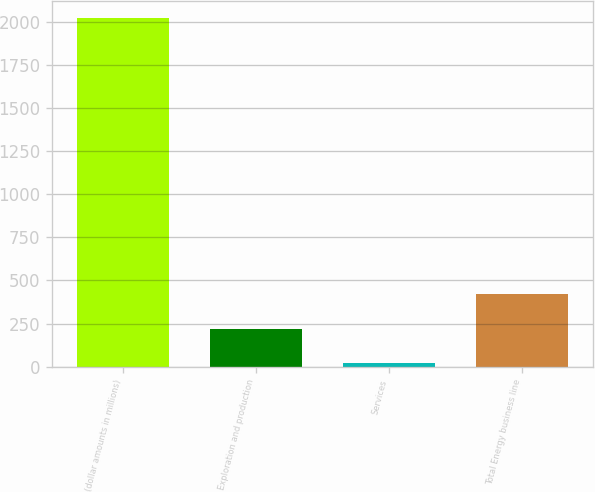<chart> <loc_0><loc_0><loc_500><loc_500><bar_chart><fcel>(dollar amounts in millions)<fcel>Exploration and production<fcel>Services<fcel>Total Energy business line<nl><fcel>2018<fcel>218.9<fcel>19<fcel>418.8<nl></chart> 